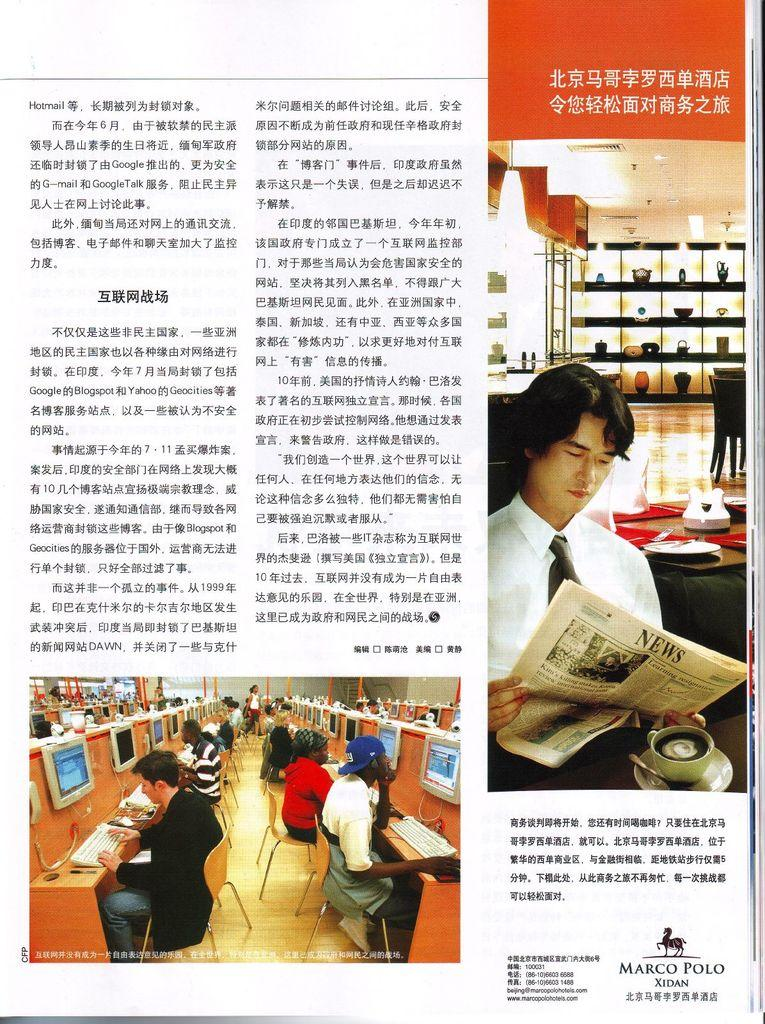<image>
Present a compact description of the photo's key features. A magazine page shows a horse logo above the words "Marco Polo Xidan". 